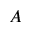Convert formula to latex. <formula><loc_0><loc_0><loc_500><loc_500>A</formula> 